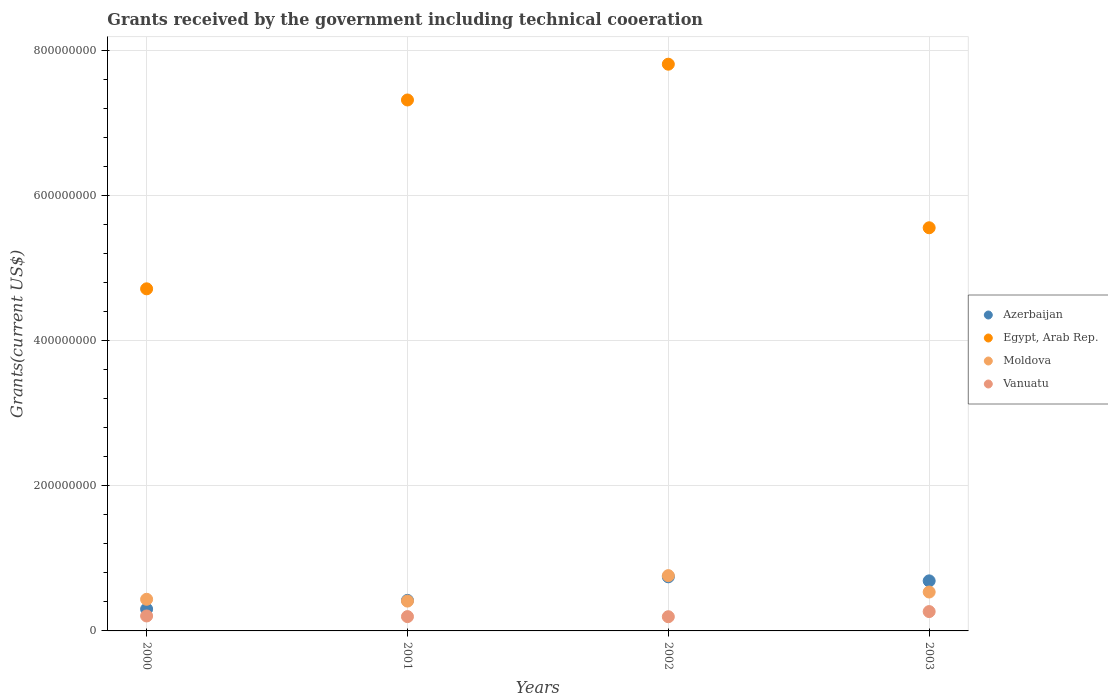How many different coloured dotlines are there?
Your answer should be very brief. 4. Is the number of dotlines equal to the number of legend labels?
Keep it short and to the point. Yes. What is the total grants received by the government in Moldova in 2001?
Give a very brief answer. 4.11e+07. Across all years, what is the maximum total grants received by the government in Moldova?
Keep it short and to the point. 7.62e+07. Across all years, what is the minimum total grants received by the government in Moldova?
Provide a short and direct response. 4.11e+07. In which year was the total grants received by the government in Azerbaijan minimum?
Your answer should be very brief. 2000. What is the total total grants received by the government in Vanuatu in the graph?
Ensure brevity in your answer.  8.66e+07. What is the difference between the total grants received by the government in Moldova in 2000 and that in 2001?
Your answer should be compact. 2.49e+06. What is the difference between the total grants received by the government in Moldova in 2002 and the total grants received by the government in Vanuatu in 2001?
Give a very brief answer. 5.65e+07. What is the average total grants received by the government in Azerbaijan per year?
Offer a terse response. 5.39e+07. In the year 2002, what is the difference between the total grants received by the government in Vanuatu and total grants received by the government in Azerbaijan?
Give a very brief answer. -5.50e+07. In how many years, is the total grants received by the government in Azerbaijan greater than 440000000 US$?
Your answer should be very brief. 0. What is the ratio of the total grants received by the government in Egypt, Arab Rep. in 2000 to that in 2002?
Your answer should be compact. 0.6. What is the difference between the highest and the second highest total grants received by the government in Egypt, Arab Rep.?
Ensure brevity in your answer.  4.93e+07. What is the difference between the highest and the lowest total grants received by the government in Moldova?
Your answer should be compact. 3.51e+07. Is the sum of the total grants received by the government in Moldova in 2001 and 2002 greater than the maximum total grants received by the government in Azerbaijan across all years?
Offer a very short reply. Yes. Is it the case that in every year, the sum of the total grants received by the government in Egypt, Arab Rep. and total grants received by the government in Vanuatu  is greater than the sum of total grants received by the government in Moldova and total grants received by the government in Azerbaijan?
Keep it short and to the point. Yes. Is it the case that in every year, the sum of the total grants received by the government in Azerbaijan and total grants received by the government in Moldova  is greater than the total grants received by the government in Vanuatu?
Offer a terse response. Yes. Is the total grants received by the government in Azerbaijan strictly greater than the total grants received by the government in Egypt, Arab Rep. over the years?
Make the answer very short. No. How many dotlines are there?
Your response must be concise. 4. Are the values on the major ticks of Y-axis written in scientific E-notation?
Offer a very short reply. No. Where does the legend appear in the graph?
Give a very brief answer. Center right. How many legend labels are there?
Provide a short and direct response. 4. What is the title of the graph?
Provide a succinct answer. Grants received by the government including technical cooeration. Does "Turks and Caicos Islands" appear as one of the legend labels in the graph?
Your answer should be compact. No. What is the label or title of the Y-axis?
Your response must be concise. Grants(current US$). What is the Grants(current US$) of Azerbaijan in 2000?
Your response must be concise. 3.01e+07. What is the Grants(current US$) in Egypt, Arab Rep. in 2000?
Offer a terse response. 4.72e+08. What is the Grants(current US$) of Moldova in 2000?
Offer a very short reply. 4.36e+07. What is the Grants(current US$) of Vanuatu in 2000?
Your response must be concise. 2.06e+07. What is the Grants(current US$) of Azerbaijan in 2001?
Make the answer very short. 4.21e+07. What is the Grants(current US$) in Egypt, Arab Rep. in 2001?
Make the answer very short. 7.32e+08. What is the Grants(current US$) in Moldova in 2001?
Ensure brevity in your answer.  4.11e+07. What is the Grants(current US$) of Vanuatu in 2001?
Offer a very short reply. 1.97e+07. What is the Grants(current US$) in Azerbaijan in 2002?
Give a very brief answer. 7.46e+07. What is the Grants(current US$) in Egypt, Arab Rep. in 2002?
Your answer should be compact. 7.81e+08. What is the Grants(current US$) in Moldova in 2002?
Provide a succinct answer. 7.62e+07. What is the Grants(current US$) of Vanuatu in 2002?
Give a very brief answer. 1.96e+07. What is the Grants(current US$) of Azerbaijan in 2003?
Offer a very short reply. 6.90e+07. What is the Grants(current US$) of Egypt, Arab Rep. in 2003?
Offer a terse response. 5.56e+08. What is the Grants(current US$) of Moldova in 2003?
Make the answer very short. 5.36e+07. What is the Grants(current US$) in Vanuatu in 2003?
Offer a terse response. 2.67e+07. Across all years, what is the maximum Grants(current US$) in Azerbaijan?
Your answer should be very brief. 7.46e+07. Across all years, what is the maximum Grants(current US$) in Egypt, Arab Rep.?
Offer a very short reply. 7.81e+08. Across all years, what is the maximum Grants(current US$) of Moldova?
Provide a succinct answer. 7.62e+07. Across all years, what is the maximum Grants(current US$) in Vanuatu?
Your answer should be compact. 2.67e+07. Across all years, what is the minimum Grants(current US$) in Azerbaijan?
Keep it short and to the point. 3.01e+07. Across all years, what is the minimum Grants(current US$) of Egypt, Arab Rep.?
Keep it short and to the point. 4.72e+08. Across all years, what is the minimum Grants(current US$) of Moldova?
Make the answer very short. 4.11e+07. Across all years, what is the minimum Grants(current US$) of Vanuatu?
Make the answer very short. 1.96e+07. What is the total Grants(current US$) in Azerbaijan in the graph?
Ensure brevity in your answer.  2.16e+08. What is the total Grants(current US$) in Egypt, Arab Rep. in the graph?
Provide a short and direct response. 2.54e+09. What is the total Grants(current US$) of Moldova in the graph?
Provide a succinct answer. 2.15e+08. What is the total Grants(current US$) in Vanuatu in the graph?
Your answer should be very brief. 8.66e+07. What is the difference between the Grants(current US$) of Azerbaijan in 2000 and that in 2001?
Offer a very short reply. -1.20e+07. What is the difference between the Grants(current US$) of Egypt, Arab Rep. in 2000 and that in 2001?
Your response must be concise. -2.60e+08. What is the difference between the Grants(current US$) in Moldova in 2000 and that in 2001?
Provide a short and direct response. 2.49e+06. What is the difference between the Grants(current US$) in Vanuatu in 2000 and that in 2001?
Offer a very short reply. 8.90e+05. What is the difference between the Grants(current US$) in Azerbaijan in 2000 and that in 2002?
Provide a succinct answer. -4.45e+07. What is the difference between the Grants(current US$) of Egypt, Arab Rep. in 2000 and that in 2002?
Offer a very short reply. -3.10e+08. What is the difference between the Grants(current US$) in Moldova in 2000 and that in 2002?
Make the answer very short. -3.26e+07. What is the difference between the Grants(current US$) of Vanuatu in 2000 and that in 2002?
Your response must be concise. 1.05e+06. What is the difference between the Grants(current US$) in Azerbaijan in 2000 and that in 2003?
Keep it short and to the point. -3.89e+07. What is the difference between the Grants(current US$) in Egypt, Arab Rep. in 2000 and that in 2003?
Your answer should be very brief. -8.42e+07. What is the difference between the Grants(current US$) in Moldova in 2000 and that in 2003?
Your answer should be very brief. -1.00e+07. What is the difference between the Grants(current US$) of Vanuatu in 2000 and that in 2003?
Provide a succinct answer. -6.05e+06. What is the difference between the Grants(current US$) in Azerbaijan in 2001 and that in 2002?
Your response must be concise. -3.25e+07. What is the difference between the Grants(current US$) of Egypt, Arab Rep. in 2001 and that in 2002?
Your response must be concise. -4.93e+07. What is the difference between the Grants(current US$) in Moldova in 2001 and that in 2002?
Provide a succinct answer. -3.51e+07. What is the difference between the Grants(current US$) in Azerbaijan in 2001 and that in 2003?
Provide a short and direct response. -2.69e+07. What is the difference between the Grants(current US$) in Egypt, Arab Rep. in 2001 and that in 2003?
Ensure brevity in your answer.  1.76e+08. What is the difference between the Grants(current US$) in Moldova in 2001 and that in 2003?
Your answer should be compact. -1.25e+07. What is the difference between the Grants(current US$) in Vanuatu in 2001 and that in 2003?
Your answer should be very brief. -6.94e+06. What is the difference between the Grants(current US$) in Azerbaijan in 2002 and that in 2003?
Your answer should be very brief. 5.58e+06. What is the difference between the Grants(current US$) in Egypt, Arab Rep. in 2002 and that in 2003?
Offer a terse response. 2.25e+08. What is the difference between the Grants(current US$) in Moldova in 2002 and that in 2003?
Provide a succinct answer. 2.26e+07. What is the difference between the Grants(current US$) in Vanuatu in 2002 and that in 2003?
Ensure brevity in your answer.  -7.10e+06. What is the difference between the Grants(current US$) of Azerbaijan in 2000 and the Grants(current US$) of Egypt, Arab Rep. in 2001?
Offer a very short reply. -7.02e+08. What is the difference between the Grants(current US$) in Azerbaijan in 2000 and the Grants(current US$) in Moldova in 2001?
Offer a terse response. -1.10e+07. What is the difference between the Grants(current US$) of Azerbaijan in 2000 and the Grants(current US$) of Vanuatu in 2001?
Your answer should be very brief. 1.04e+07. What is the difference between the Grants(current US$) in Egypt, Arab Rep. in 2000 and the Grants(current US$) in Moldova in 2001?
Give a very brief answer. 4.30e+08. What is the difference between the Grants(current US$) in Egypt, Arab Rep. in 2000 and the Grants(current US$) in Vanuatu in 2001?
Keep it short and to the point. 4.52e+08. What is the difference between the Grants(current US$) of Moldova in 2000 and the Grants(current US$) of Vanuatu in 2001?
Provide a short and direct response. 2.39e+07. What is the difference between the Grants(current US$) in Azerbaijan in 2000 and the Grants(current US$) in Egypt, Arab Rep. in 2002?
Offer a terse response. -7.51e+08. What is the difference between the Grants(current US$) of Azerbaijan in 2000 and the Grants(current US$) of Moldova in 2002?
Offer a terse response. -4.61e+07. What is the difference between the Grants(current US$) of Azerbaijan in 2000 and the Grants(current US$) of Vanuatu in 2002?
Your response must be concise. 1.05e+07. What is the difference between the Grants(current US$) in Egypt, Arab Rep. in 2000 and the Grants(current US$) in Moldova in 2002?
Offer a terse response. 3.95e+08. What is the difference between the Grants(current US$) in Egypt, Arab Rep. in 2000 and the Grants(current US$) in Vanuatu in 2002?
Your response must be concise. 4.52e+08. What is the difference between the Grants(current US$) of Moldova in 2000 and the Grants(current US$) of Vanuatu in 2002?
Offer a terse response. 2.40e+07. What is the difference between the Grants(current US$) of Azerbaijan in 2000 and the Grants(current US$) of Egypt, Arab Rep. in 2003?
Provide a succinct answer. -5.26e+08. What is the difference between the Grants(current US$) in Azerbaijan in 2000 and the Grants(current US$) in Moldova in 2003?
Make the answer very short. -2.35e+07. What is the difference between the Grants(current US$) of Azerbaijan in 2000 and the Grants(current US$) of Vanuatu in 2003?
Your response must be concise. 3.41e+06. What is the difference between the Grants(current US$) in Egypt, Arab Rep. in 2000 and the Grants(current US$) in Moldova in 2003?
Offer a very short reply. 4.18e+08. What is the difference between the Grants(current US$) of Egypt, Arab Rep. in 2000 and the Grants(current US$) of Vanuatu in 2003?
Give a very brief answer. 4.45e+08. What is the difference between the Grants(current US$) of Moldova in 2000 and the Grants(current US$) of Vanuatu in 2003?
Provide a succinct answer. 1.70e+07. What is the difference between the Grants(current US$) of Azerbaijan in 2001 and the Grants(current US$) of Egypt, Arab Rep. in 2002?
Make the answer very short. -7.39e+08. What is the difference between the Grants(current US$) in Azerbaijan in 2001 and the Grants(current US$) in Moldova in 2002?
Your answer should be very brief. -3.41e+07. What is the difference between the Grants(current US$) of Azerbaijan in 2001 and the Grants(current US$) of Vanuatu in 2002?
Your answer should be very brief. 2.25e+07. What is the difference between the Grants(current US$) in Egypt, Arab Rep. in 2001 and the Grants(current US$) in Moldova in 2002?
Offer a terse response. 6.56e+08. What is the difference between the Grants(current US$) in Egypt, Arab Rep. in 2001 and the Grants(current US$) in Vanuatu in 2002?
Make the answer very short. 7.12e+08. What is the difference between the Grants(current US$) of Moldova in 2001 and the Grants(current US$) of Vanuatu in 2002?
Provide a short and direct response. 2.16e+07. What is the difference between the Grants(current US$) of Azerbaijan in 2001 and the Grants(current US$) of Egypt, Arab Rep. in 2003?
Make the answer very short. -5.14e+08. What is the difference between the Grants(current US$) of Azerbaijan in 2001 and the Grants(current US$) of Moldova in 2003?
Provide a short and direct response. -1.15e+07. What is the difference between the Grants(current US$) in Azerbaijan in 2001 and the Grants(current US$) in Vanuatu in 2003?
Offer a very short reply. 1.54e+07. What is the difference between the Grants(current US$) of Egypt, Arab Rep. in 2001 and the Grants(current US$) of Moldova in 2003?
Your answer should be compact. 6.78e+08. What is the difference between the Grants(current US$) of Egypt, Arab Rep. in 2001 and the Grants(current US$) of Vanuatu in 2003?
Ensure brevity in your answer.  7.05e+08. What is the difference between the Grants(current US$) of Moldova in 2001 and the Grants(current US$) of Vanuatu in 2003?
Your response must be concise. 1.45e+07. What is the difference between the Grants(current US$) of Azerbaijan in 2002 and the Grants(current US$) of Egypt, Arab Rep. in 2003?
Make the answer very short. -4.81e+08. What is the difference between the Grants(current US$) of Azerbaijan in 2002 and the Grants(current US$) of Moldova in 2003?
Offer a very short reply. 2.10e+07. What is the difference between the Grants(current US$) of Azerbaijan in 2002 and the Grants(current US$) of Vanuatu in 2003?
Give a very brief answer. 4.79e+07. What is the difference between the Grants(current US$) of Egypt, Arab Rep. in 2002 and the Grants(current US$) of Moldova in 2003?
Ensure brevity in your answer.  7.28e+08. What is the difference between the Grants(current US$) of Egypt, Arab Rep. in 2002 and the Grants(current US$) of Vanuatu in 2003?
Offer a very short reply. 7.55e+08. What is the difference between the Grants(current US$) of Moldova in 2002 and the Grants(current US$) of Vanuatu in 2003?
Provide a succinct answer. 4.96e+07. What is the average Grants(current US$) in Azerbaijan per year?
Offer a very short reply. 5.39e+07. What is the average Grants(current US$) in Egypt, Arab Rep. per year?
Your answer should be very brief. 6.35e+08. What is the average Grants(current US$) of Moldova per year?
Your answer should be compact. 5.36e+07. What is the average Grants(current US$) of Vanuatu per year?
Keep it short and to the point. 2.16e+07. In the year 2000, what is the difference between the Grants(current US$) of Azerbaijan and Grants(current US$) of Egypt, Arab Rep.?
Offer a very short reply. -4.42e+08. In the year 2000, what is the difference between the Grants(current US$) in Azerbaijan and Grants(current US$) in Moldova?
Offer a terse response. -1.35e+07. In the year 2000, what is the difference between the Grants(current US$) of Azerbaijan and Grants(current US$) of Vanuatu?
Your response must be concise. 9.46e+06. In the year 2000, what is the difference between the Grants(current US$) of Egypt, Arab Rep. and Grants(current US$) of Moldova?
Offer a very short reply. 4.28e+08. In the year 2000, what is the difference between the Grants(current US$) in Egypt, Arab Rep. and Grants(current US$) in Vanuatu?
Your answer should be very brief. 4.51e+08. In the year 2000, what is the difference between the Grants(current US$) in Moldova and Grants(current US$) in Vanuatu?
Offer a very short reply. 2.30e+07. In the year 2001, what is the difference between the Grants(current US$) of Azerbaijan and Grants(current US$) of Egypt, Arab Rep.?
Offer a very short reply. -6.90e+08. In the year 2001, what is the difference between the Grants(current US$) in Azerbaijan and Grants(current US$) in Moldova?
Make the answer very short. 9.70e+05. In the year 2001, what is the difference between the Grants(current US$) in Azerbaijan and Grants(current US$) in Vanuatu?
Offer a terse response. 2.24e+07. In the year 2001, what is the difference between the Grants(current US$) in Egypt, Arab Rep. and Grants(current US$) in Moldova?
Your response must be concise. 6.91e+08. In the year 2001, what is the difference between the Grants(current US$) of Egypt, Arab Rep. and Grants(current US$) of Vanuatu?
Your answer should be very brief. 7.12e+08. In the year 2001, what is the difference between the Grants(current US$) of Moldova and Grants(current US$) of Vanuatu?
Provide a succinct answer. 2.14e+07. In the year 2002, what is the difference between the Grants(current US$) of Azerbaijan and Grants(current US$) of Egypt, Arab Rep.?
Give a very brief answer. -7.07e+08. In the year 2002, what is the difference between the Grants(current US$) in Azerbaijan and Grants(current US$) in Moldova?
Ensure brevity in your answer.  -1.64e+06. In the year 2002, what is the difference between the Grants(current US$) in Azerbaijan and Grants(current US$) in Vanuatu?
Give a very brief answer. 5.50e+07. In the year 2002, what is the difference between the Grants(current US$) in Egypt, Arab Rep. and Grants(current US$) in Moldova?
Offer a terse response. 7.05e+08. In the year 2002, what is the difference between the Grants(current US$) of Egypt, Arab Rep. and Grants(current US$) of Vanuatu?
Keep it short and to the point. 7.62e+08. In the year 2002, what is the difference between the Grants(current US$) of Moldova and Grants(current US$) of Vanuatu?
Offer a terse response. 5.66e+07. In the year 2003, what is the difference between the Grants(current US$) in Azerbaijan and Grants(current US$) in Egypt, Arab Rep.?
Your answer should be compact. -4.87e+08. In the year 2003, what is the difference between the Grants(current US$) in Azerbaijan and Grants(current US$) in Moldova?
Your answer should be compact. 1.54e+07. In the year 2003, what is the difference between the Grants(current US$) of Azerbaijan and Grants(current US$) of Vanuatu?
Make the answer very short. 4.23e+07. In the year 2003, what is the difference between the Grants(current US$) in Egypt, Arab Rep. and Grants(current US$) in Moldova?
Your response must be concise. 5.02e+08. In the year 2003, what is the difference between the Grants(current US$) of Egypt, Arab Rep. and Grants(current US$) of Vanuatu?
Make the answer very short. 5.29e+08. In the year 2003, what is the difference between the Grants(current US$) of Moldova and Grants(current US$) of Vanuatu?
Make the answer very short. 2.70e+07. What is the ratio of the Grants(current US$) of Azerbaijan in 2000 to that in 2001?
Offer a very short reply. 0.71. What is the ratio of the Grants(current US$) of Egypt, Arab Rep. in 2000 to that in 2001?
Give a very brief answer. 0.64. What is the ratio of the Grants(current US$) of Moldova in 2000 to that in 2001?
Give a very brief answer. 1.06. What is the ratio of the Grants(current US$) in Vanuatu in 2000 to that in 2001?
Provide a succinct answer. 1.05. What is the ratio of the Grants(current US$) of Azerbaijan in 2000 to that in 2002?
Your response must be concise. 0.4. What is the ratio of the Grants(current US$) in Egypt, Arab Rep. in 2000 to that in 2002?
Ensure brevity in your answer.  0.6. What is the ratio of the Grants(current US$) of Moldova in 2000 to that in 2002?
Keep it short and to the point. 0.57. What is the ratio of the Grants(current US$) in Vanuatu in 2000 to that in 2002?
Your answer should be compact. 1.05. What is the ratio of the Grants(current US$) of Azerbaijan in 2000 to that in 2003?
Make the answer very short. 0.44. What is the ratio of the Grants(current US$) in Egypt, Arab Rep. in 2000 to that in 2003?
Provide a succinct answer. 0.85. What is the ratio of the Grants(current US$) of Moldova in 2000 to that in 2003?
Your response must be concise. 0.81. What is the ratio of the Grants(current US$) in Vanuatu in 2000 to that in 2003?
Ensure brevity in your answer.  0.77. What is the ratio of the Grants(current US$) in Azerbaijan in 2001 to that in 2002?
Your answer should be compact. 0.56. What is the ratio of the Grants(current US$) in Egypt, Arab Rep. in 2001 to that in 2002?
Make the answer very short. 0.94. What is the ratio of the Grants(current US$) in Moldova in 2001 to that in 2002?
Your answer should be compact. 0.54. What is the ratio of the Grants(current US$) in Vanuatu in 2001 to that in 2002?
Your answer should be compact. 1.01. What is the ratio of the Grants(current US$) of Azerbaijan in 2001 to that in 2003?
Offer a terse response. 0.61. What is the ratio of the Grants(current US$) of Egypt, Arab Rep. in 2001 to that in 2003?
Offer a terse response. 1.32. What is the ratio of the Grants(current US$) in Moldova in 2001 to that in 2003?
Your answer should be compact. 0.77. What is the ratio of the Grants(current US$) of Vanuatu in 2001 to that in 2003?
Give a very brief answer. 0.74. What is the ratio of the Grants(current US$) of Azerbaijan in 2002 to that in 2003?
Your answer should be very brief. 1.08. What is the ratio of the Grants(current US$) in Egypt, Arab Rep. in 2002 to that in 2003?
Give a very brief answer. 1.41. What is the ratio of the Grants(current US$) in Moldova in 2002 to that in 2003?
Your answer should be very brief. 1.42. What is the ratio of the Grants(current US$) of Vanuatu in 2002 to that in 2003?
Make the answer very short. 0.73. What is the difference between the highest and the second highest Grants(current US$) of Azerbaijan?
Ensure brevity in your answer.  5.58e+06. What is the difference between the highest and the second highest Grants(current US$) in Egypt, Arab Rep.?
Give a very brief answer. 4.93e+07. What is the difference between the highest and the second highest Grants(current US$) of Moldova?
Keep it short and to the point. 2.26e+07. What is the difference between the highest and the second highest Grants(current US$) in Vanuatu?
Provide a short and direct response. 6.05e+06. What is the difference between the highest and the lowest Grants(current US$) in Azerbaijan?
Provide a succinct answer. 4.45e+07. What is the difference between the highest and the lowest Grants(current US$) of Egypt, Arab Rep.?
Provide a succinct answer. 3.10e+08. What is the difference between the highest and the lowest Grants(current US$) in Moldova?
Offer a terse response. 3.51e+07. What is the difference between the highest and the lowest Grants(current US$) in Vanuatu?
Offer a terse response. 7.10e+06. 